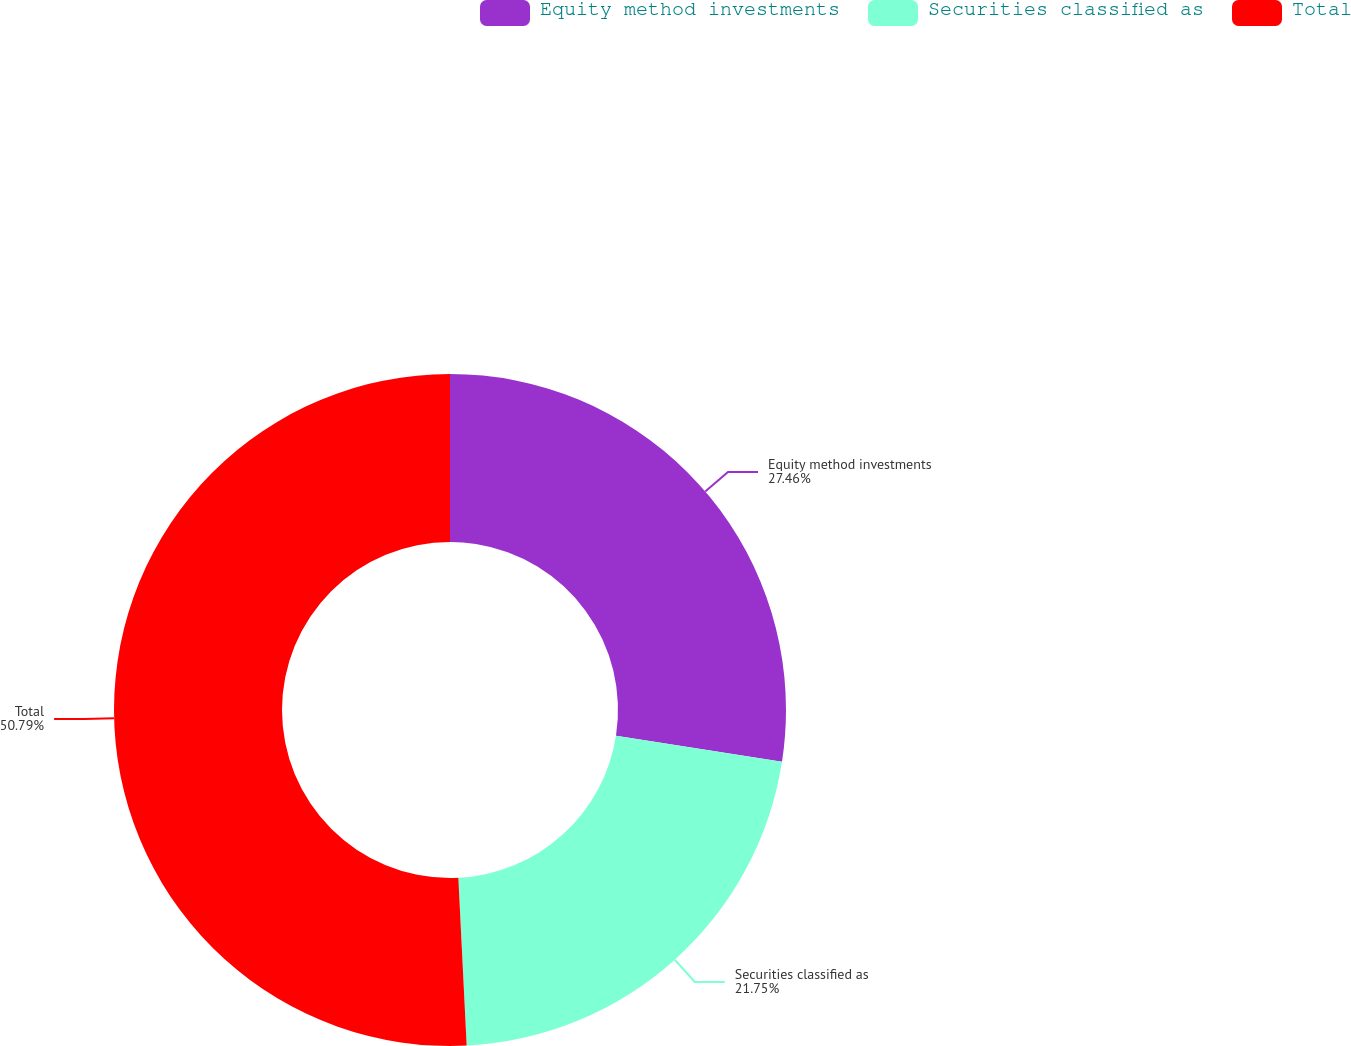Convert chart. <chart><loc_0><loc_0><loc_500><loc_500><pie_chart><fcel>Equity method investments<fcel>Securities classified as<fcel>Total<nl><fcel>27.46%<fcel>21.75%<fcel>50.79%<nl></chart> 